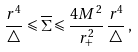<formula> <loc_0><loc_0><loc_500><loc_500>\frac { r ^ { 4 } } { \triangle } \leqslant \overline { \Sigma } \leqslant \frac { 4 M ^ { 2 } } { r _ { + } ^ { 2 } } \, \frac { r ^ { 4 } } { \triangle } \, , \,</formula> 